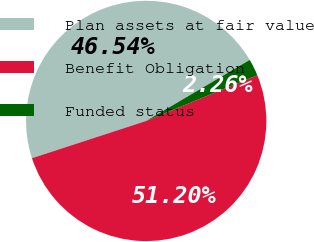Convert chart. <chart><loc_0><loc_0><loc_500><loc_500><pie_chart><fcel>Plan assets at fair value<fcel>Benefit Obligation<fcel>Funded status<nl><fcel>46.54%<fcel>51.19%<fcel>2.26%<nl></chart> 